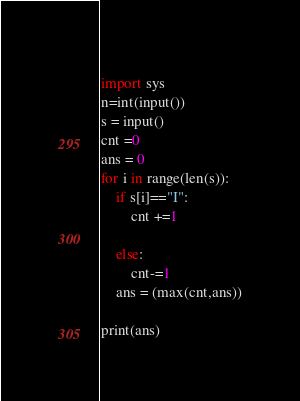Convert code to text. <code><loc_0><loc_0><loc_500><loc_500><_Python_>    
import sys
n=int(input())
s = input()
cnt =0
ans = 0
for i in range(len(s)):
    if s[i]=="I":
        cnt +=1
        
    else:
        cnt-=1
    ans = (max(cnt,ans))

print(ans)

</code> 